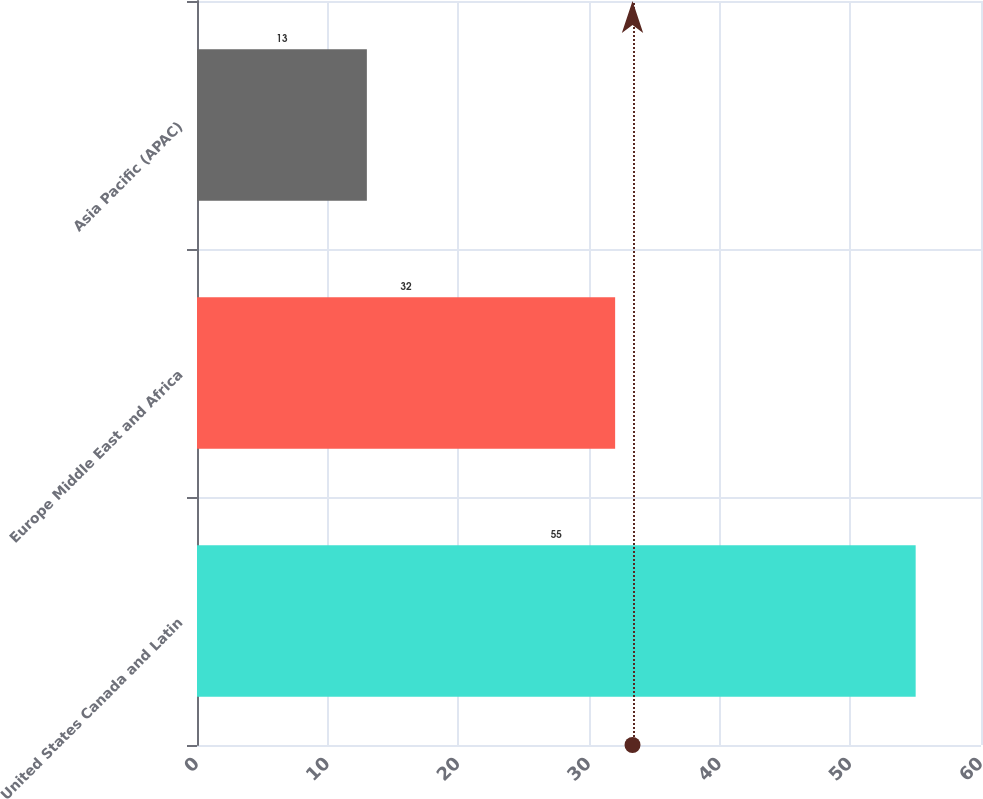Convert chart to OTSL. <chart><loc_0><loc_0><loc_500><loc_500><bar_chart><fcel>United States Canada and Latin<fcel>Europe Middle East and Africa<fcel>Asia Pacific (APAC)<nl><fcel>55<fcel>32<fcel>13<nl></chart> 